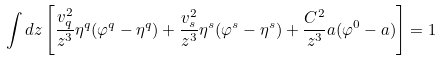<formula> <loc_0><loc_0><loc_500><loc_500>\int d z \left [ \frac { v _ { q } ^ { 2 } } { z ^ { 3 } } \eta ^ { q } ( \varphi ^ { q } - \eta ^ { q } ) + \frac { v _ { s } ^ { 2 } } { z ^ { 3 } } \eta ^ { s } ( \varphi ^ { s } - \eta ^ { s } ) + \frac { C ^ { 2 } } { z ^ { 3 } } a ( \varphi ^ { 0 } - a ) \right ] = 1</formula> 